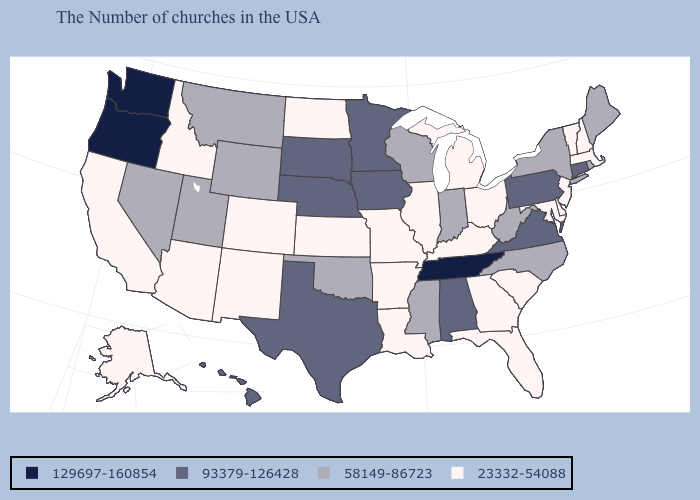Name the states that have a value in the range 129697-160854?
Keep it brief. Tennessee, Washington, Oregon. Name the states that have a value in the range 23332-54088?
Answer briefly. Massachusetts, New Hampshire, Vermont, New Jersey, Delaware, Maryland, South Carolina, Ohio, Florida, Georgia, Michigan, Kentucky, Illinois, Louisiana, Missouri, Arkansas, Kansas, North Dakota, Colorado, New Mexico, Arizona, Idaho, California, Alaska. Among the states that border South Carolina , which have the lowest value?
Be succinct. Georgia. Name the states that have a value in the range 129697-160854?
Keep it brief. Tennessee, Washington, Oregon. What is the value of Virginia?
Answer briefly. 93379-126428. What is the value of Connecticut?
Keep it brief. 93379-126428. What is the value of South Dakota?
Quick response, please. 93379-126428. Name the states that have a value in the range 23332-54088?
Give a very brief answer. Massachusetts, New Hampshire, Vermont, New Jersey, Delaware, Maryland, South Carolina, Ohio, Florida, Georgia, Michigan, Kentucky, Illinois, Louisiana, Missouri, Arkansas, Kansas, North Dakota, Colorado, New Mexico, Arizona, Idaho, California, Alaska. What is the value of New Hampshire?
Concise answer only. 23332-54088. What is the value of Hawaii?
Keep it brief. 93379-126428. Is the legend a continuous bar?
Answer briefly. No. Name the states that have a value in the range 23332-54088?
Concise answer only. Massachusetts, New Hampshire, Vermont, New Jersey, Delaware, Maryland, South Carolina, Ohio, Florida, Georgia, Michigan, Kentucky, Illinois, Louisiana, Missouri, Arkansas, Kansas, North Dakota, Colorado, New Mexico, Arizona, Idaho, California, Alaska. Does Nevada have a higher value than Massachusetts?
Write a very short answer. Yes. Does Kansas have a higher value than Nevada?
Write a very short answer. No. What is the highest value in the USA?
Short answer required. 129697-160854. 